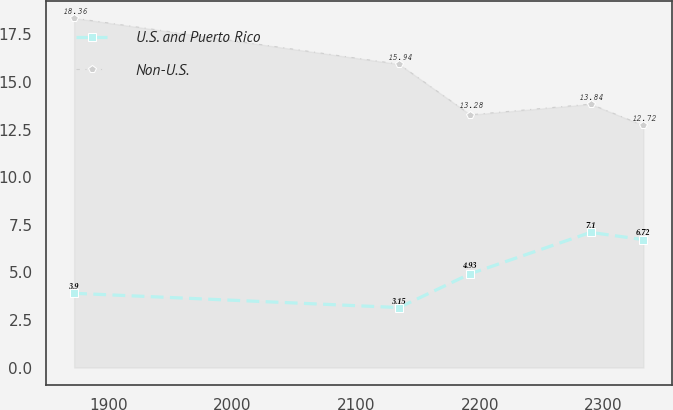Convert chart to OTSL. <chart><loc_0><loc_0><loc_500><loc_500><line_chart><ecel><fcel>U.S. and Puerto Rico<fcel>Non-U.S.<nl><fcel>1872.19<fcel>3.9<fcel>18.36<nl><fcel>2134.64<fcel>3.15<fcel>15.94<nl><fcel>2192.36<fcel>4.93<fcel>13.28<nl><fcel>2289.46<fcel>7.1<fcel>13.84<nl><fcel>2332.1<fcel>6.72<fcel>12.72<nl></chart> 